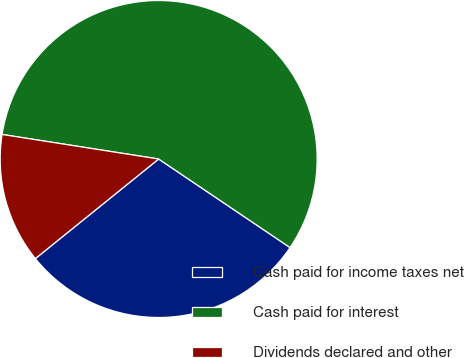<chart> <loc_0><loc_0><loc_500><loc_500><pie_chart><fcel>Cash paid for income taxes net<fcel>Cash paid for interest<fcel>Dividends declared and other<nl><fcel>29.75%<fcel>56.96%<fcel>13.29%<nl></chart> 